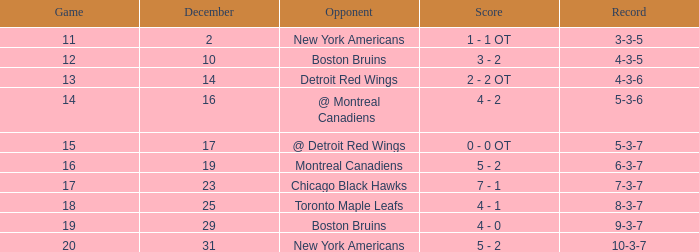In which game is the highest record a 4-3-6? 13.0. 